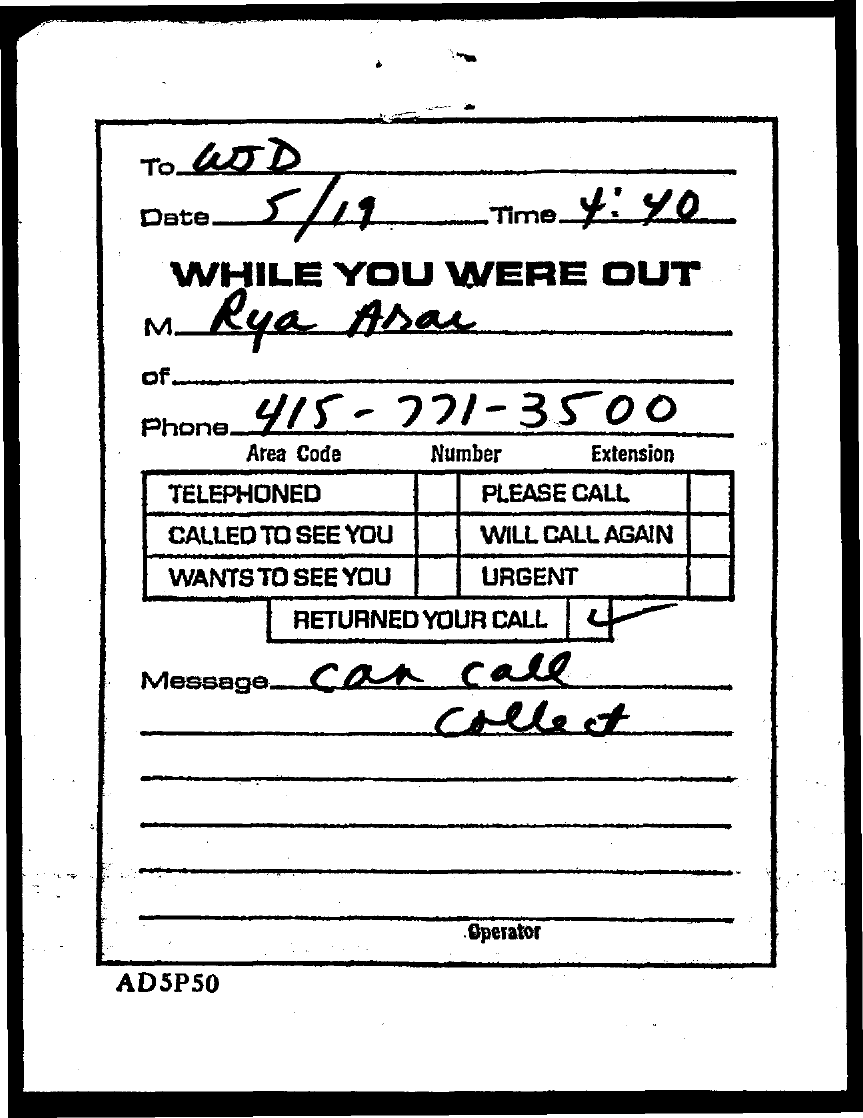What is the date mentioned in the document?
Your answer should be compact. 5/19. What is the time mentioned in the document?
Provide a succinct answer. 4:40. What is the area code?
Give a very brief answer. 415. 